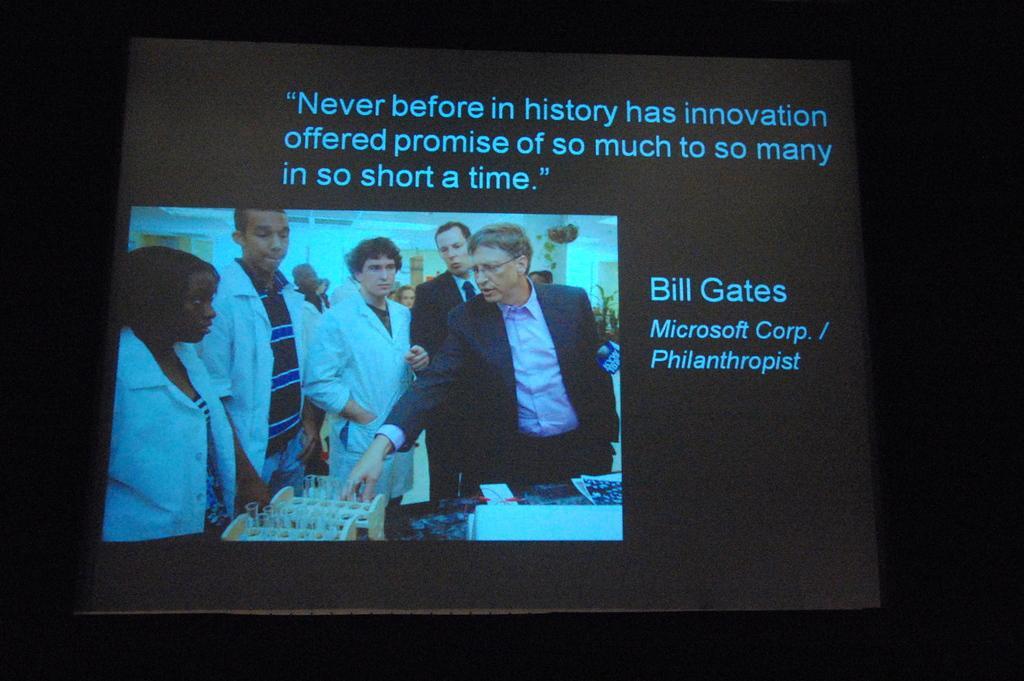How would you summarize this image in a sentence or two? In this image we can see one picture. In that picture on projector screen is there, in that screen some text, some plants, one window, some objects on the wall, some people are standing and some objects are on the table. 